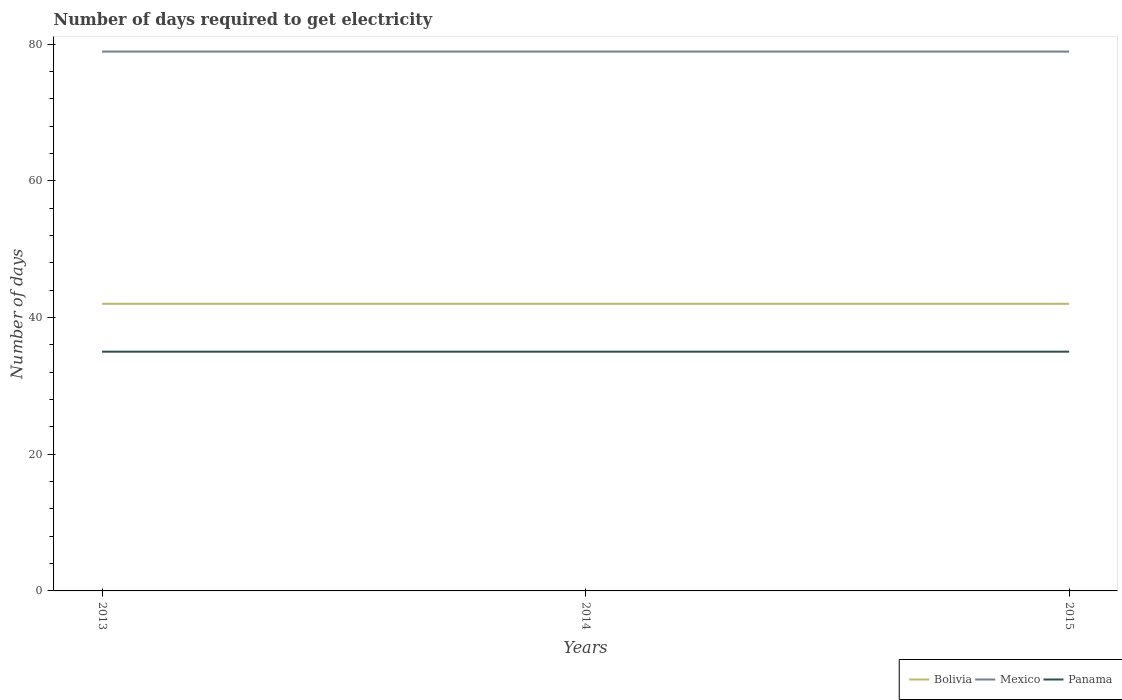Does the line corresponding to Panama intersect with the line corresponding to Mexico?
Give a very brief answer. No. Across all years, what is the maximum number of days required to get electricity in in Panama?
Make the answer very short. 35. In which year was the number of days required to get electricity in in Bolivia maximum?
Ensure brevity in your answer.  2013. How many lines are there?
Your answer should be compact. 3. Does the graph contain any zero values?
Your answer should be very brief. No. How many legend labels are there?
Give a very brief answer. 3. How are the legend labels stacked?
Provide a succinct answer. Horizontal. What is the title of the graph?
Make the answer very short. Number of days required to get electricity. What is the label or title of the Y-axis?
Offer a terse response. Number of days. What is the Number of days in Mexico in 2013?
Offer a very short reply. 78.9. What is the Number of days in Mexico in 2014?
Ensure brevity in your answer.  78.9. What is the Number of days of Mexico in 2015?
Keep it short and to the point. 78.9. Across all years, what is the maximum Number of days of Mexico?
Give a very brief answer. 78.9. Across all years, what is the minimum Number of days in Bolivia?
Your response must be concise. 42. Across all years, what is the minimum Number of days of Mexico?
Ensure brevity in your answer.  78.9. What is the total Number of days of Bolivia in the graph?
Provide a short and direct response. 126. What is the total Number of days in Mexico in the graph?
Offer a terse response. 236.7. What is the total Number of days in Panama in the graph?
Provide a short and direct response. 105. What is the difference between the Number of days in Bolivia in 2013 and that in 2014?
Offer a very short reply. 0. What is the difference between the Number of days in Mexico in 2013 and that in 2014?
Provide a short and direct response. 0. What is the difference between the Number of days in Panama in 2013 and that in 2014?
Your answer should be very brief. 0. What is the difference between the Number of days of Mexico in 2013 and that in 2015?
Offer a very short reply. 0. What is the difference between the Number of days of Panama in 2013 and that in 2015?
Offer a terse response. 0. What is the difference between the Number of days of Bolivia in 2014 and that in 2015?
Give a very brief answer. 0. What is the difference between the Number of days of Bolivia in 2013 and the Number of days of Mexico in 2014?
Offer a terse response. -36.9. What is the difference between the Number of days of Bolivia in 2013 and the Number of days of Panama in 2014?
Provide a succinct answer. 7. What is the difference between the Number of days of Mexico in 2013 and the Number of days of Panama in 2014?
Provide a succinct answer. 43.9. What is the difference between the Number of days of Bolivia in 2013 and the Number of days of Mexico in 2015?
Give a very brief answer. -36.9. What is the difference between the Number of days in Bolivia in 2013 and the Number of days in Panama in 2015?
Offer a very short reply. 7. What is the difference between the Number of days in Mexico in 2013 and the Number of days in Panama in 2015?
Ensure brevity in your answer.  43.9. What is the difference between the Number of days of Bolivia in 2014 and the Number of days of Mexico in 2015?
Provide a short and direct response. -36.9. What is the difference between the Number of days in Bolivia in 2014 and the Number of days in Panama in 2015?
Give a very brief answer. 7. What is the difference between the Number of days of Mexico in 2014 and the Number of days of Panama in 2015?
Your response must be concise. 43.9. What is the average Number of days of Mexico per year?
Your answer should be very brief. 78.9. What is the average Number of days of Panama per year?
Your answer should be very brief. 35. In the year 2013, what is the difference between the Number of days in Bolivia and Number of days in Mexico?
Offer a very short reply. -36.9. In the year 2013, what is the difference between the Number of days in Mexico and Number of days in Panama?
Provide a short and direct response. 43.9. In the year 2014, what is the difference between the Number of days in Bolivia and Number of days in Mexico?
Make the answer very short. -36.9. In the year 2014, what is the difference between the Number of days in Mexico and Number of days in Panama?
Ensure brevity in your answer.  43.9. In the year 2015, what is the difference between the Number of days of Bolivia and Number of days of Mexico?
Give a very brief answer. -36.9. In the year 2015, what is the difference between the Number of days of Mexico and Number of days of Panama?
Your answer should be compact. 43.9. What is the ratio of the Number of days in Panama in 2013 to that in 2014?
Keep it short and to the point. 1. What is the ratio of the Number of days in Panama in 2013 to that in 2015?
Keep it short and to the point. 1. What is the ratio of the Number of days of Bolivia in 2014 to that in 2015?
Make the answer very short. 1. What is the ratio of the Number of days in Panama in 2014 to that in 2015?
Make the answer very short. 1. What is the difference between the highest and the second highest Number of days in Bolivia?
Keep it short and to the point. 0. What is the difference between the highest and the second highest Number of days in Mexico?
Ensure brevity in your answer.  0. What is the difference between the highest and the lowest Number of days of Bolivia?
Your answer should be compact. 0. What is the difference between the highest and the lowest Number of days in Panama?
Your answer should be very brief. 0. 